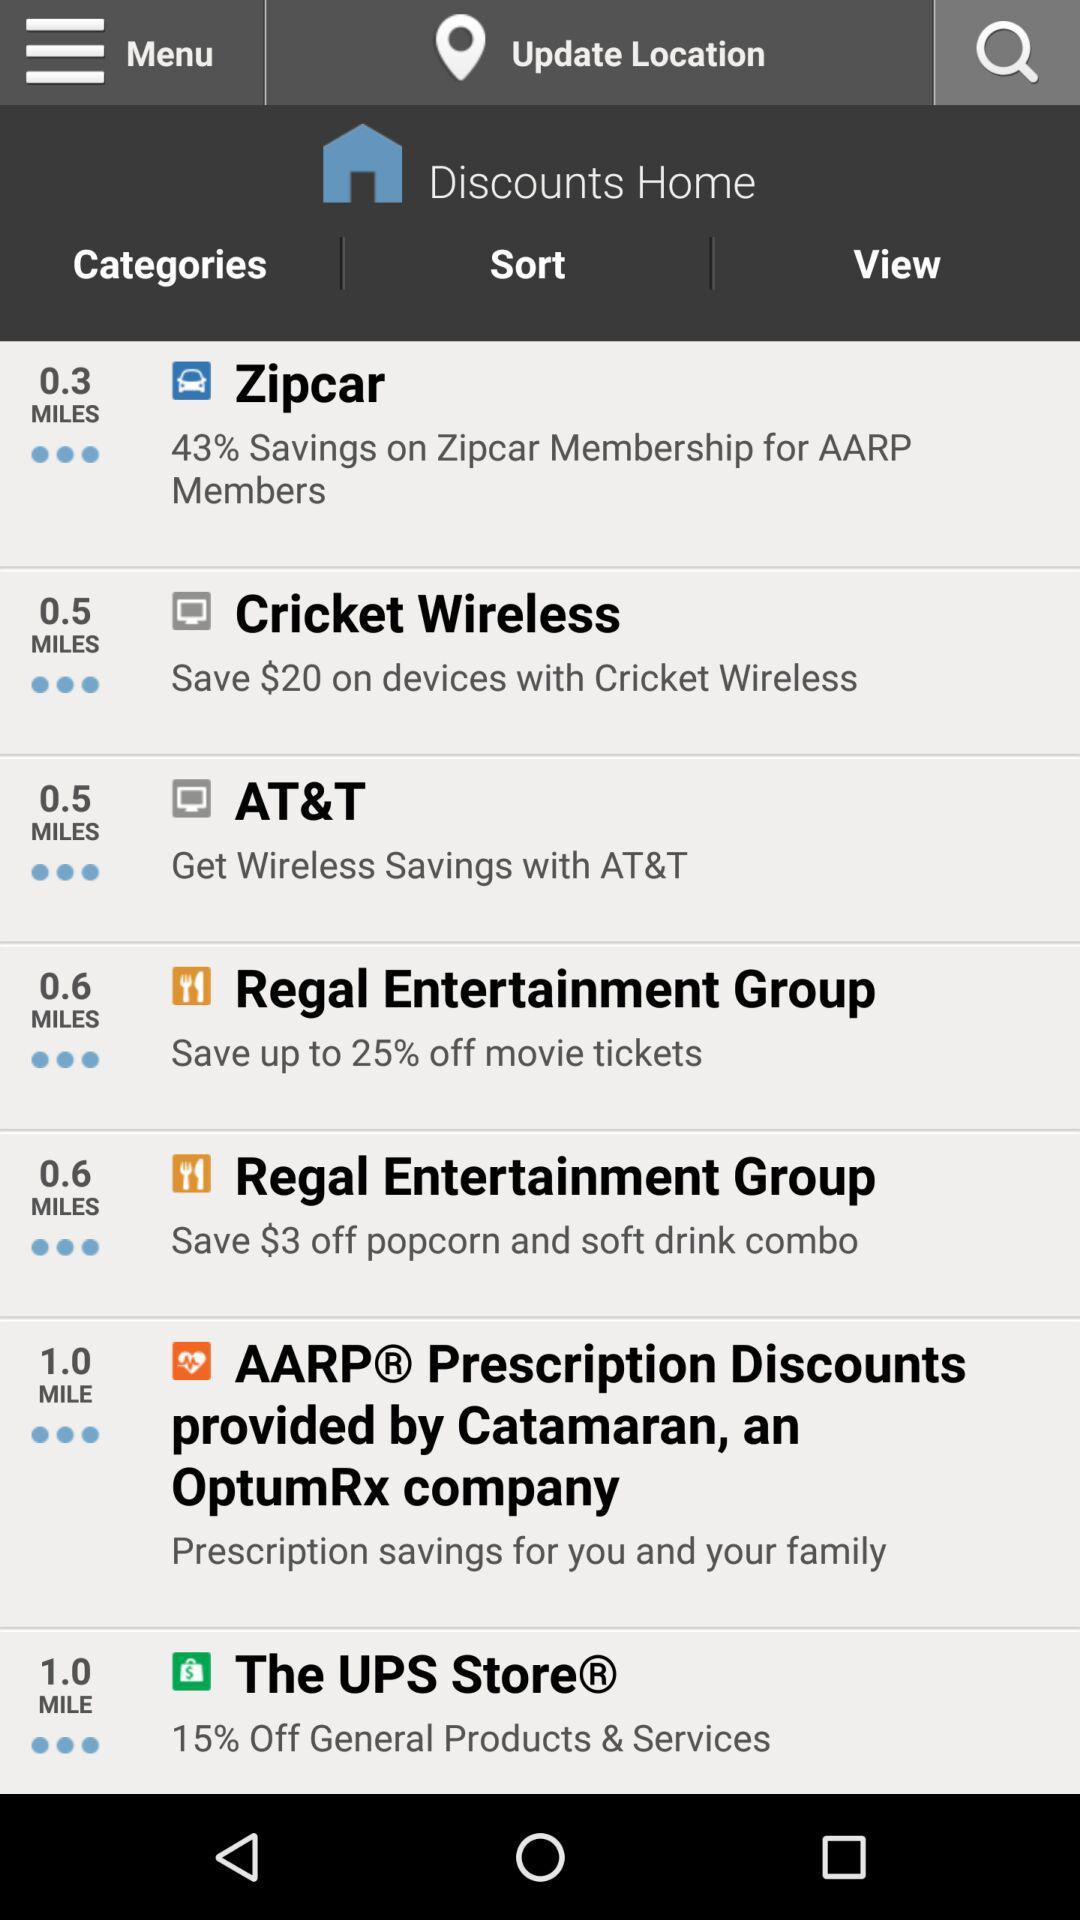How far is the "Zipcar" store? The "Zipcar" store is 0.3 miles away. 